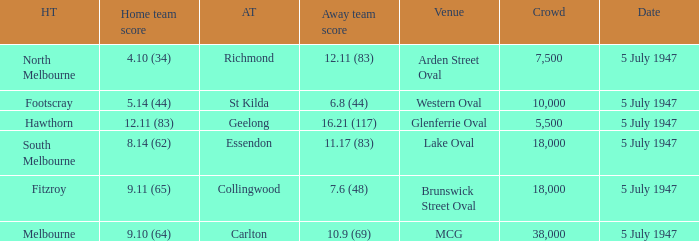What did the home team score when the away team scored 12.11 (83)? 4.10 (34). 